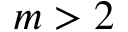Convert formula to latex. <formula><loc_0><loc_0><loc_500><loc_500>m > 2</formula> 